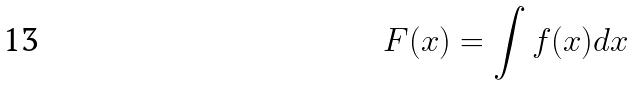Convert formula to latex. <formula><loc_0><loc_0><loc_500><loc_500>F ( x ) = \int f ( x ) d x</formula> 